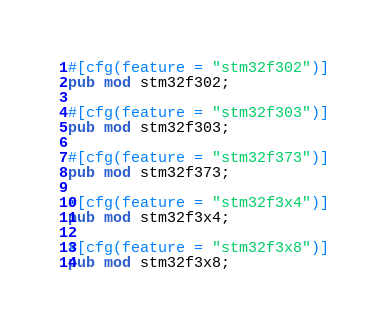Convert code to text. <code><loc_0><loc_0><loc_500><loc_500><_Rust_>#[cfg(feature = "stm32f302")]
pub mod stm32f302;

#[cfg(feature = "stm32f303")]
pub mod stm32f303;

#[cfg(feature = "stm32f373")]
pub mod stm32f373;

#[cfg(feature = "stm32f3x4")]
pub mod stm32f3x4;

#[cfg(feature = "stm32f3x8")]
pub mod stm32f3x8;

</code> 